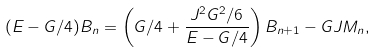<formula> <loc_0><loc_0><loc_500><loc_500>( E - G / 4 ) B _ { n } = \left ( G / 4 + \frac { J ^ { 2 } G ^ { 2 } / 6 } { E - G / 4 } \right ) B _ { n + 1 } - G J M _ { n } ,</formula> 